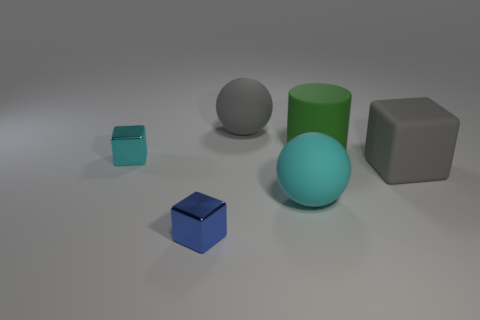What is the color of the other metallic object that is the same shape as the blue thing?
Your answer should be compact. Cyan. How many matte balls have the same color as the cylinder?
Provide a short and direct response. 0. Does the cylinder that is behind the gray matte block have the same size as the cyan object to the left of the small blue metallic cube?
Provide a succinct answer. No. Do the cyan matte sphere and the block right of the blue block have the same size?
Keep it short and to the point. Yes. What size is the gray rubber ball?
Provide a succinct answer. Large. There is a big cylinder that is the same material as the cyan ball; what is its color?
Your answer should be very brief. Green. How many big gray balls are made of the same material as the small cyan object?
Your answer should be compact. 0. How many things are gray objects or blocks behind the big cyan thing?
Your response must be concise. 3. Are the gray object that is in front of the large cylinder and the green cylinder made of the same material?
Ensure brevity in your answer.  Yes. The metal object that is the same size as the blue block is what color?
Provide a succinct answer. Cyan. 